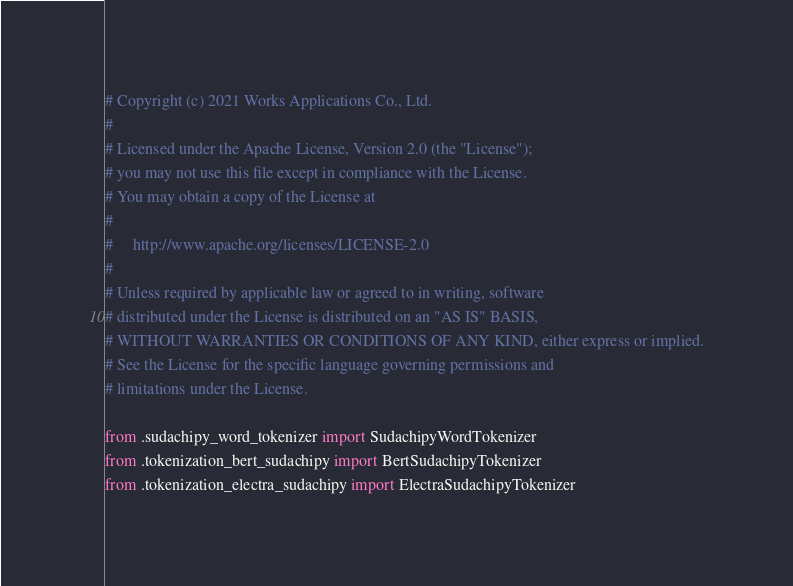<code> <loc_0><loc_0><loc_500><loc_500><_Python_># Copyright (c) 2021 Works Applications Co., Ltd.
#
# Licensed under the Apache License, Version 2.0 (the "License");
# you may not use this file except in compliance with the License.
# You may obtain a copy of the License at
#
#     http://www.apache.org/licenses/LICENSE-2.0
#
# Unless required by applicable law or agreed to in writing, software
# distributed under the License is distributed on an "AS IS" BASIS,
# WITHOUT WARRANTIES OR CONDITIONS OF ANY KIND, either express or implied.
# See the License for the specific language governing permissions and
# limitations under the License.

from .sudachipy_word_tokenizer import SudachipyWordTokenizer
from .tokenization_bert_sudachipy import BertSudachipyTokenizer
from .tokenization_electra_sudachipy import ElectraSudachipyTokenizer
</code> 